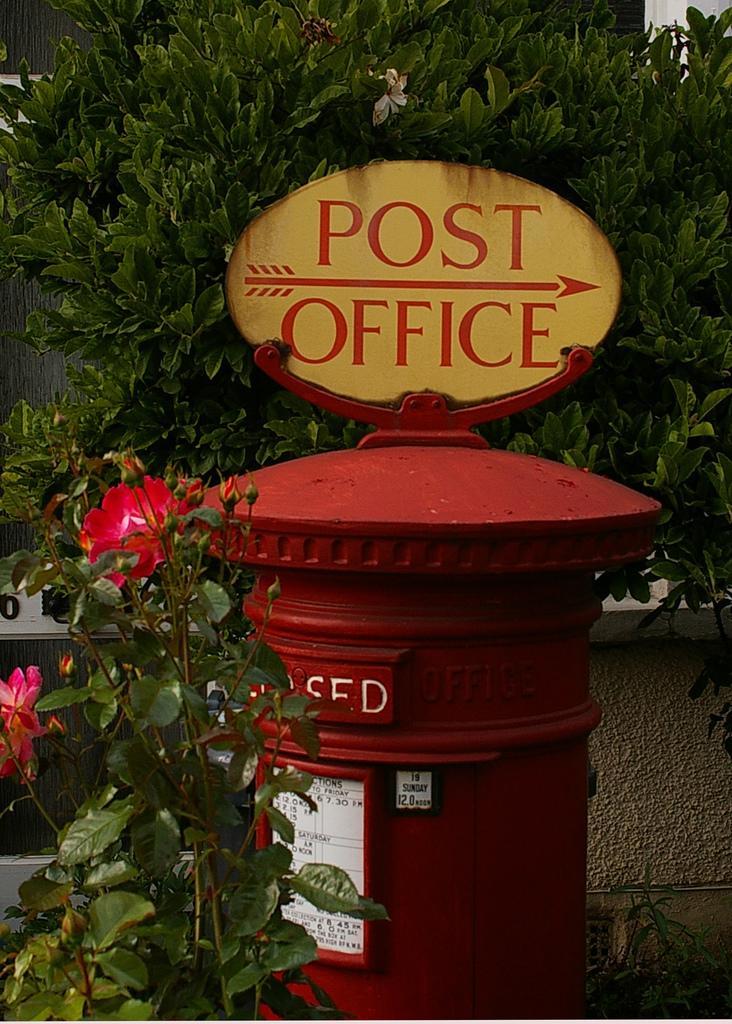Could you give a brief overview of what you see in this image? In this image, we can see a post box with name board and stickers. Here we can see flowers and plants. Background we can see tree and wall. 